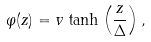<formula> <loc_0><loc_0><loc_500><loc_500>\varphi ( z ) = v \, \tanh \left ( \frac { z } { \Delta } \right ) ,</formula> 